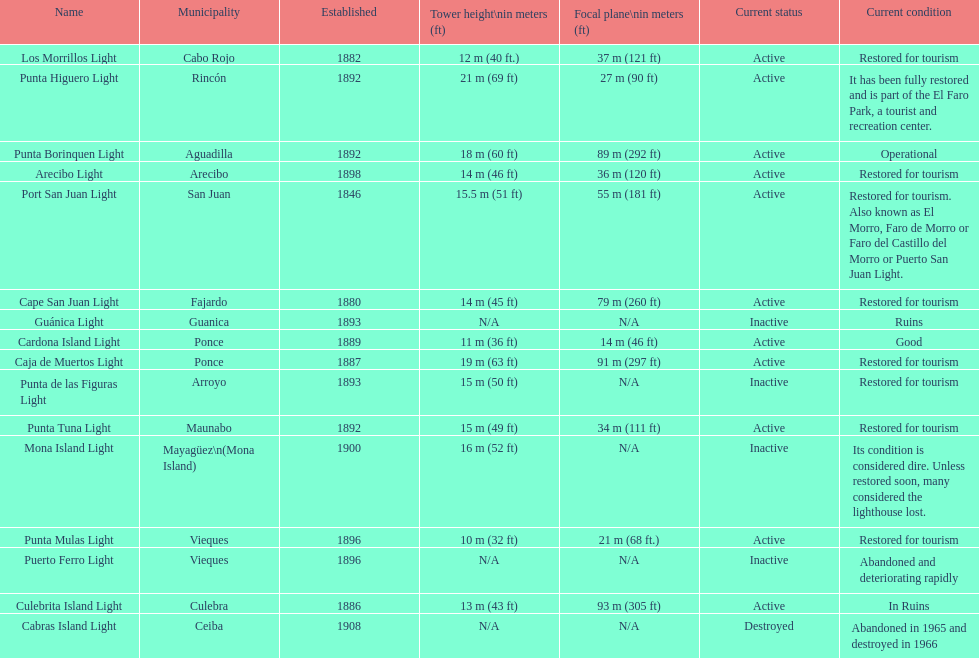Would you be able to parse every entry in this table? {'header': ['Name', 'Municipality', 'Established', 'Tower height\\nin meters (ft)', 'Focal plane\\nin meters (ft)', 'Current status', 'Current condition'], 'rows': [['Los Morrillos Light', 'Cabo Rojo', '1882', '12\xa0m (40\xa0ft.)', '37\xa0m (121\xa0ft)', 'Active', 'Restored for tourism'], ['Punta Higuero Light', 'Rincón', '1892', '21\xa0m (69\xa0ft)', '27\xa0m (90\xa0ft)', 'Active', 'It has been fully restored and is part of the El Faro Park, a tourist and recreation center.'], ['Punta Borinquen Light', 'Aguadilla', '1892', '18\xa0m (60\xa0ft)', '89\xa0m (292\xa0ft)', 'Active', 'Operational'], ['Arecibo Light', 'Arecibo', '1898', '14\xa0m (46\xa0ft)', '36\xa0m (120\xa0ft)', 'Active', 'Restored for tourism'], ['Port San Juan Light', 'San Juan', '1846', '15.5\xa0m (51\xa0ft)', '55\xa0m (181\xa0ft)', 'Active', 'Restored for tourism. Also known as El Morro, Faro de Morro or Faro del Castillo del Morro or Puerto San Juan Light.'], ['Cape San Juan Light', 'Fajardo', '1880', '14\xa0m (45\xa0ft)', '79\xa0m (260\xa0ft)', 'Active', 'Restored for tourism'], ['Guánica Light', 'Guanica', '1893', 'N/A', 'N/A', 'Inactive', 'Ruins'], ['Cardona Island Light', 'Ponce', '1889', '11\xa0m (36\xa0ft)', '14\xa0m (46\xa0ft)', 'Active', 'Good'], ['Caja de Muertos Light', 'Ponce', '1887', '19\xa0m (63\xa0ft)', '91\xa0m (297\xa0ft)', 'Active', 'Restored for tourism'], ['Punta de las Figuras Light', 'Arroyo', '1893', '15\xa0m (50\xa0ft)', 'N/A', 'Inactive', 'Restored for tourism'], ['Punta Tuna Light', 'Maunabo', '1892', '15\xa0m (49\xa0ft)', '34\xa0m (111\xa0ft)', 'Active', 'Restored for tourism'], ['Mona Island Light', 'Mayagüez\\n(Mona Island)', '1900', '16\xa0m (52\xa0ft)', 'N/A', 'Inactive', 'Its condition is considered dire. Unless restored soon, many considered the lighthouse lost.'], ['Punta Mulas Light', 'Vieques', '1896', '10\xa0m (32\xa0ft)', '21\xa0m (68\xa0ft.)', 'Active', 'Restored for tourism'], ['Puerto Ferro Light', 'Vieques', '1896', 'N/A', 'N/A', 'Inactive', 'Abandoned and deteriorating rapidly'], ['Culebrita Island Light', 'Culebra', '1886', '13\xa0m (43\xa0ft)', '93\xa0m (305\xa0ft)', 'Active', 'In Ruins'], ['Cabras Island Light', 'Ceiba', '1908', 'N/A', 'N/A', 'Destroyed', 'Abandoned in 1965 and destroyed in 1966']]} Which local government area was the first to be created? San Juan. 